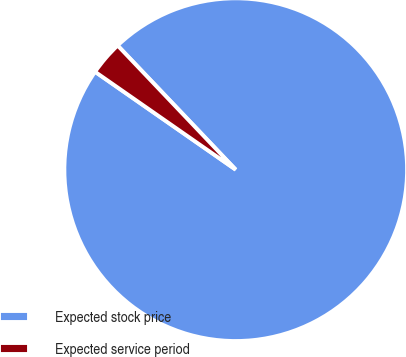Convert chart. <chart><loc_0><loc_0><loc_500><loc_500><pie_chart><fcel>Expected stock price<fcel>Expected service period<nl><fcel>96.78%<fcel>3.22%<nl></chart> 